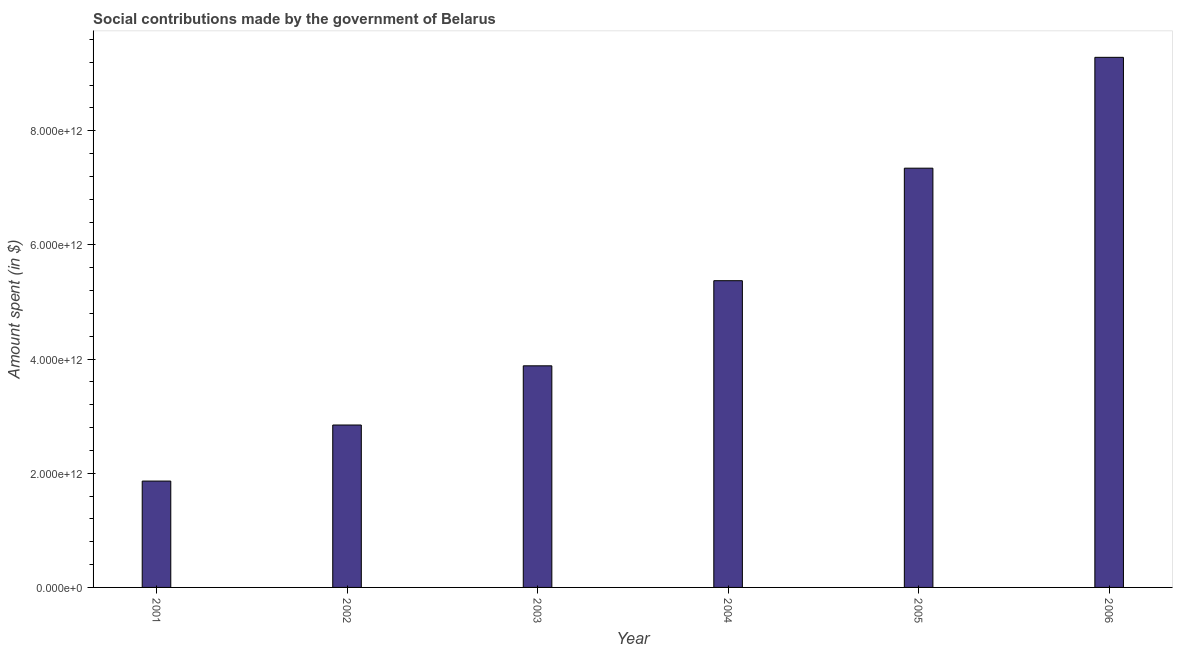What is the title of the graph?
Give a very brief answer. Social contributions made by the government of Belarus. What is the label or title of the X-axis?
Keep it short and to the point. Year. What is the label or title of the Y-axis?
Keep it short and to the point. Amount spent (in $). What is the amount spent in making social contributions in 2002?
Provide a succinct answer. 2.85e+12. Across all years, what is the maximum amount spent in making social contributions?
Make the answer very short. 9.29e+12. Across all years, what is the minimum amount spent in making social contributions?
Give a very brief answer. 1.86e+12. What is the sum of the amount spent in making social contributions?
Your answer should be compact. 3.06e+13. What is the difference between the amount spent in making social contributions in 2001 and 2006?
Ensure brevity in your answer.  -7.42e+12. What is the average amount spent in making social contributions per year?
Give a very brief answer. 5.10e+12. What is the median amount spent in making social contributions?
Give a very brief answer. 4.63e+12. In how many years, is the amount spent in making social contributions greater than 8400000000000 $?
Give a very brief answer. 1. What is the ratio of the amount spent in making social contributions in 2002 to that in 2003?
Your response must be concise. 0.73. Is the amount spent in making social contributions in 2005 less than that in 2006?
Ensure brevity in your answer.  Yes. Is the difference between the amount spent in making social contributions in 2002 and 2004 greater than the difference between any two years?
Offer a very short reply. No. What is the difference between the highest and the second highest amount spent in making social contributions?
Provide a short and direct response. 1.94e+12. What is the difference between the highest and the lowest amount spent in making social contributions?
Ensure brevity in your answer.  7.42e+12. In how many years, is the amount spent in making social contributions greater than the average amount spent in making social contributions taken over all years?
Keep it short and to the point. 3. How many bars are there?
Your answer should be compact. 6. How many years are there in the graph?
Keep it short and to the point. 6. What is the difference between two consecutive major ticks on the Y-axis?
Ensure brevity in your answer.  2.00e+12. Are the values on the major ticks of Y-axis written in scientific E-notation?
Keep it short and to the point. Yes. What is the Amount spent (in $) in 2001?
Keep it short and to the point. 1.86e+12. What is the Amount spent (in $) of 2002?
Keep it short and to the point. 2.85e+12. What is the Amount spent (in $) in 2003?
Your answer should be compact. 3.88e+12. What is the Amount spent (in $) in 2004?
Keep it short and to the point. 5.37e+12. What is the Amount spent (in $) in 2005?
Ensure brevity in your answer.  7.35e+12. What is the Amount spent (in $) in 2006?
Make the answer very short. 9.29e+12. What is the difference between the Amount spent (in $) in 2001 and 2002?
Provide a succinct answer. -9.82e+11. What is the difference between the Amount spent (in $) in 2001 and 2003?
Provide a short and direct response. -2.02e+12. What is the difference between the Amount spent (in $) in 2001 and 2004?
Your answer should be very brief. -3.51e+12. What is the difference between the Amount spent (in $) in 2001 and 2005?
Provide a succinct answer. -5.48e+12. What is the difference between the Amount spent (in $) in 2001 and 2006?
Make the answer very short. -7.42e+12. What is the difference between the Amount spent (in $) in 2002 and 2003?
Provide a succinct answer. -1.04e+12. What is the difference between the Amount spent (in $) in 2002 and 2004?
Your answer should be compact. -2.53e+12. What is the difference between the Amount spent (in $) in 2002 and 2005?
Make the answer very short. -4.50e+12. What is the difference between the Amount spent (in $) in 2002 and 2006?
Provide a short and direct response. -6.44e+12. What is the difference between the Amount spent (in $) in 2003 and 2004?
Keep it short and to the point. -1.49e+12. What is the difference between the Amount spent (in $) in 2003 and 2005?
Your response must be concise. -3.46e+12. What is the difference between the Amount spent (in $) in 2003 and 2006?
Provide a short and direct response. -5.40e+12. What is the difference between the Amount spent (in $) in 2004 and 2005?
Offer a very short reply. -1.97e+12. What is the difference between the Amount spent (in $) in 2004 and 2006?
Provide a short and direct response. -3.91e+12. What is the difference between the Amount spent (in $) in 2005 and 2006?
Offer a terse response. -1.94e+12. What is the ratio of the Amount spent (in $) in 2001 to that in 2002?
Your answer should be very brief. 0.66. What is the ratio of the Amount spent (in $) in 2001 to that in 2003?
Your response must be concise. 0.48. What is the ratio of the Amount spent (in $) in 2001 to that in 2004?
Your response must be concise. 0.35. What is the ratio of the Amount spent (in $) in 2001 to that in 2005?
Provide a succinct answer. 0.25. What is the ratio of the Amount spent (in $) in 2001 to that in 2006?
Ensure brevity in your answer.  0.2. What is the ratio of the Amount spent (in $) in 2002 to that in 2003?
Provide a short and direct response. 0.73. What is the ratio of the Amount spent (in $) in 2002 to that in 2004?
Offer a very short reply. 0.53. What is the ratio of the Amount spent (in $) in 2002 to that in 2005?
Provide a succinct answer. 0.39. What is the ratio of the Amount spent (in $) in 2002 to that in 2006?
Provide a short and direct response. 0.31. What is the ratio of the Amount spent (in $) in 2003 to that in 2004?
Make the answer very short. 0.72. What is the ratio of the Amount spent (in $) in 2003 to that in 2005?
Ensure brevity in your answer.  0.53. What is the ratio of the Amount spent (in $) in 2003 to that in 2006?
Give a very brief answer. 0.42. What is the ratio of the Amount spent (in $) in 2004 to that in 2005?
Your answer should be very brief. 0.73. What is the ratio of the Amount spent (in $) in 2004 to that in 2006?
Ensure brevity in your answer.  0.58. What is the ratio of the Amount spent (in $) in 2005 to that in 2006?
Provide a short and direct response. 0.79. 